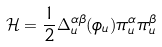Convert formula to latex. <formula><loc_0><loc_0><loc_500><loc_500>\mathcal { H } = \frac { 1 } { 2 } \Delta _ { u } ^ { \alpha \beta } ( { \phi } _ { u } ) \pi _ { u } ^ { \alpha } { \pi } _ { u } ^ { \beta }</formula> 